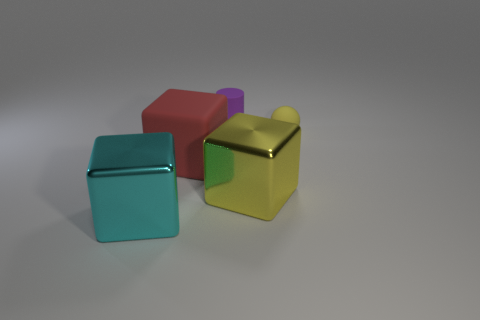Are there any red shiny things of the same size as the cyan block?
Offer a very short reply. No. What is the material of the cylinder that is left of the metal thing that is behind the cyan metal thing?
Make the answer very short. Rubber. What number of metallic things have the same color as the rubber sphere?
Provide a short and direct response. 1. There is a tiny object that is made of the same material as the tiny purple cylinder; what shape is it?
Make the answer very short. Sphere. How big is the metallic thing that is behind the cyan block?
Your response must be concise. Large. Is the number of large things that are on the right side of the matte cube the same as the number of big cyan cubes to the right of the big yellow metallic object?
Your answer should be compact. No. The metal object on the left side of the tiny rubber thing that is to the left of the metallic block that is on the right side of the cyan thing is what color?
Ensure brevity in your answer.  Cyan. What number of rubber objects are in front of the cylinder and behind the small sphere?
Offer a terse response. 0. There is a metallic block that is behind the big cyan cube; is it the same color as the matte thing behind the small rubber sphere?
Give a very brief answer. No. Is there any other thing that has the same material as the large red block?
Give a very brief answer. Yes. 